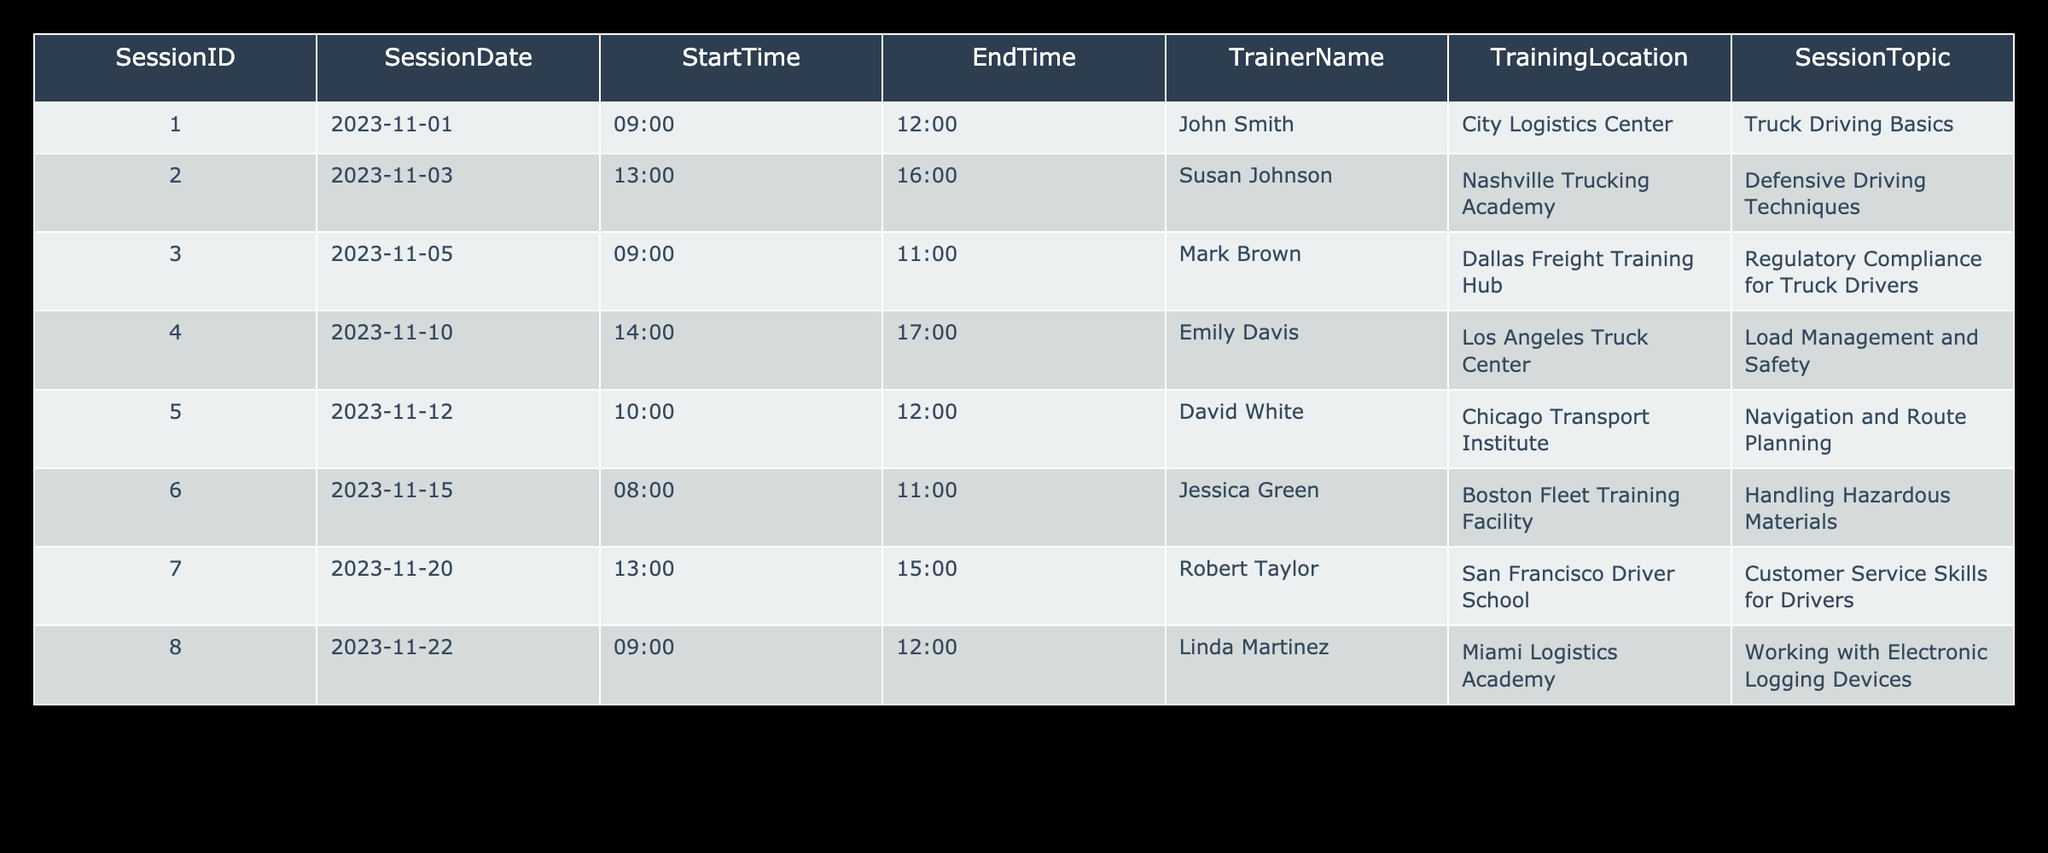What is the topic of the training session scheduled for November 5th? The table indicates that the training session on November 5th is titled "Regulatory Compliance for Truck Drivers," which can be directly found in the SessionTopic column corresponding to SessionID 3.
Answer: Regulatory Compliance for Truck Drivers Who is the trainer for the session on November 22nd? By checking the entry for November 22nd, we see that Linda Martinez is listed as the trainer in the TrainerName column for that session.
Answer: Linda Martinez Is there a training session that covers Load Management and Safety? Referring to the SessionTopic column, we can see that the session titled "Load Management and Safety" is listed for November 10th. Therefore, the answer is yes.
Answer: Yes How many hours is the training session on Handling Hazardous Materials? The session on Handling Hazardous Materials is scheduled from 8:00 to 11:00 on November 15th. To find the duration, we subtract the start time from the end time: 11:00 - 8:00 equals 3 hours.
Answer: 3 hours Which training session has the earliest start time, and what is its topic? The earliest start time is 08:00 for the session on Handling Hazardous Materials on November 15th. This can be determined by comparing all start times in the StartTime column. The corresponding topic is "Handling Hazardous Materials".
Answer: Handling Hazardous Materials How many training sessions are scheduled in the first two weeks of November? We need to count how many sessions fall between November 1st and November 14th. The sessions on November 1st, November 3rd, November 5th, and November 10th fall within this period. Therefore, there are a total of 4 sessions.
Answer: 4 sessions What is the latest date of the training sessions listed? By surveying the SessionDate column, the latest date provided is November 22nd. This was found by comparing all the dates formatted as YYYY-MM-DD and determining which is the most recent.
Answer: November 22nd Which session covers Customer Service Skills for Drivers, and when does it take place? Looking at the SessionTopic column, we find that the Customer Service Skills for Drivers session is scheduled for November 20th, as indicated by its corresponding entry.
Answer: November 20th 